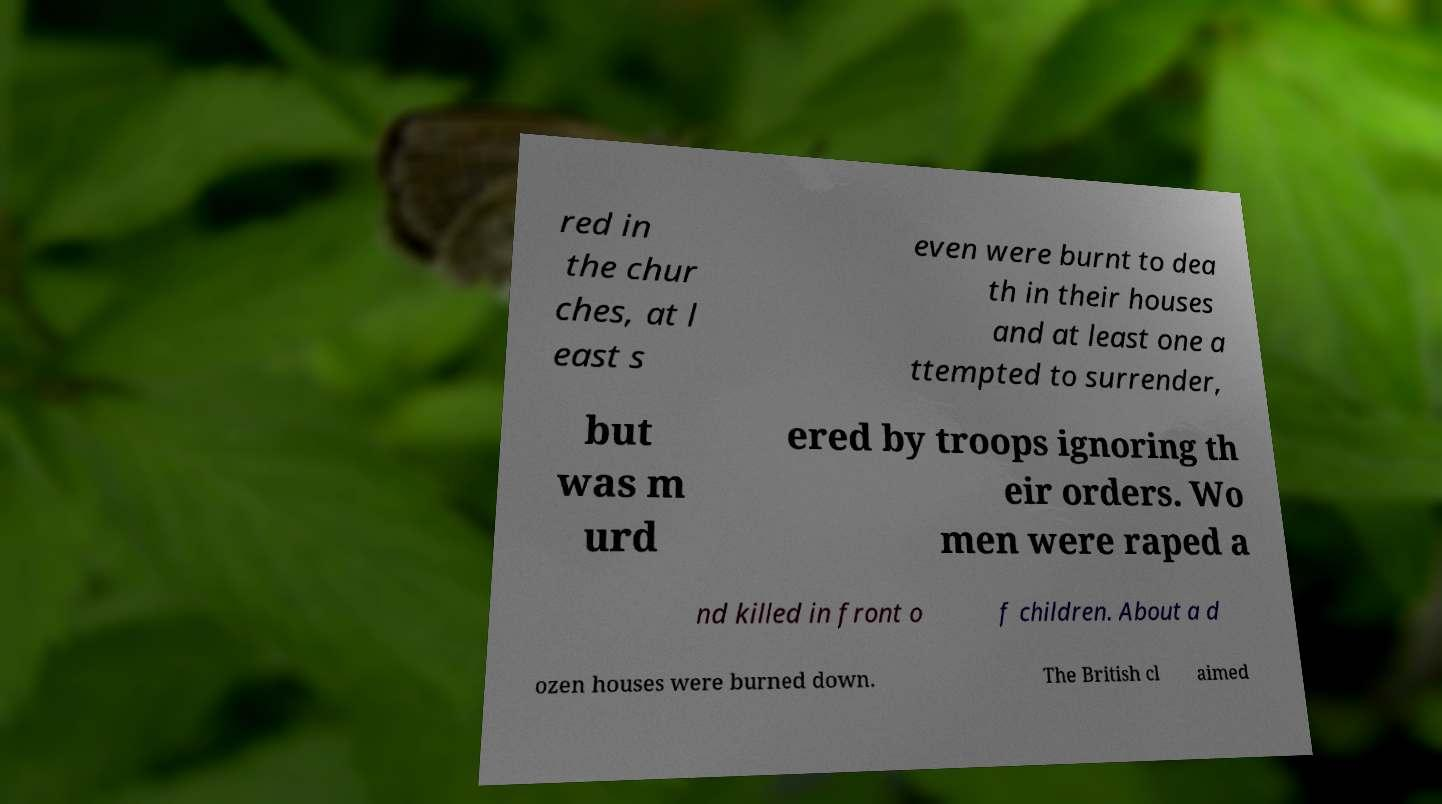Could you extract and type out the text from this image? red in the chur ches, at l east s even were burnt to dea th in their houses and at least one a ttempted to surrender, but was m urd ered by troops ignoring th eir orders. Wo men were raped a nd killed in front o f children. About a d ozen houses were burned down. The British cl aimed 